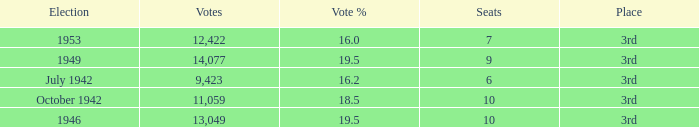Name the total number of seats for votes % more than 19.5 0.0. 